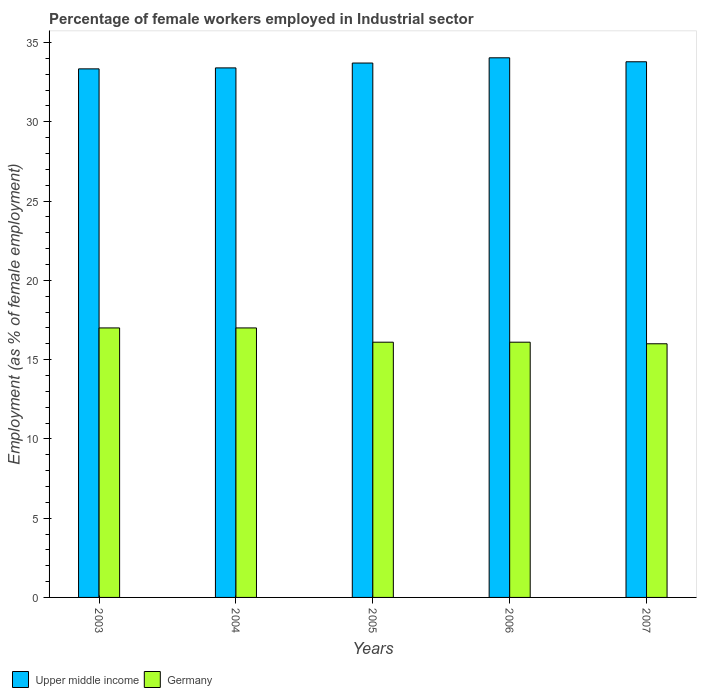How many different coloured bars are there?
Provide a succinct answer. 2. Are the number of bars per tick equal to the number of legend labels?
Provide a succinct answer. Yes. How many bars are there on the 4th tick from the left?
Offer a very short reply. 2. What is the percentage of females employed in Industrial sector in Upper middle income in 2004?
Your answer should be compact. 33.4. Across all years, what is the maximum percentage of females employed in Industrial sector in Upper middle income?
Offer a terse response. 34.04. What is the total percentage of females employed in Industrial sector in Upper middle income in the graph?
Provide a succinct answer. 168.28. What is the difference between the percentage of females employed in Industrial sector in Upper middle income in 2005 and that in 2007?
Your response must be concise. -0.08. What is the difference between the percentage of females employed in Industrial sector in Upper middle income in 2007 and the percentage of females employed in Industrial sector in Germany in 2006?
Ensure brevity in your answer.  17.69. What is the average percentage of females employed in Industrial sector in Upper middle income per year?
Offer a very short reply. 33.66. In the year 2006, what is the difference between the percentage of females employed in Industrial sector in Upper middle income and percentage of females employed in Industrial sector in Germany?
Provide a succinct answer. 17.94. In how many years, is the percentage of females employed in Industrial sector in Upper middle income greater than 17 %?
Keep it short and to the point. 5. What is the ratio of the percentage of females employed in Industrial sector in Germany in 2006 to that in 2007?
Keep it short and to the point. 1.01. What is the difference between the highest and the second highest percentage of females employed in Industrial sector in Germany?
Your response must be concise. 0. What is the difference between the highest and the lowest percentage of females employed in Industrial sector in Upper middle income?
Keep it short and to the point. 0.7. In how many years, is the percentage of females employed in Industrial sector in Upper middle income greater than the average percentage of females employed in Industrial sector in Upper middle income taken over all years?
Your answer should be compact. 3. Is the sum of the percentage of females employed in Industrial sector in Germany in 2003 and 2004 greater than the maximum percentage of females employed in Industrial sector in Upper middle income across all years?
Your answer should be very brief. No. What does the 1st bar from the left in 2007 represents?
Ensure brevity in your answer.  Upper middle income. What does the 2nd bar from the right in 2004 represents?
Keep it short and to the point. Upper middle income. How many bars are there?
Give a very brief answer. 10. How many years are there in the graph?
Ensure brevity in your answer.  5. Does the graph contain grids?
Your answer should be compact. No. How many legend labels are there?
Offer a terse response. 2. How are the legend labels stacked?
Provide a succinct answer. Horizontal. What is the title of the graph?
Your answer should be very brief. Percentage of female workers employed in Industrial sector. Does "Maldives" appear as one of the legend labels in the graph?
Provide a succinct answer. No. What is the label or title of the X-axis?
Offer a terse response. Years. What is the label or title of the Y-axis?
Provide a succinct answer. Employment (as % of female employment). What is the Employment (as % of female employment) of Upper middle income in 2003?
Provide a short and direct response. 33.34. What is the Employment (as % of female employment) in Germany in 2003?
Provide a succinct answer. 17. What is the Employment (as % of female employment) of Upper middle income in 2004?
Offer a terse response. 33.4. What is the Employment (as % of female employment) in Germany in 2004?
Provide a succinct answer. 17. What is the Employment (as % of female employment) of Upper middle income in 2005?
Your answer should be very brief. 33.71. What is the Employment (as % of female employment) in Germany in 2005?
Offer a terse response. 16.1. What is the Employment (as % of female employment) of Upper middle income in 2006?
Provide a succinct answer. 34.04. What is the Employment (as % of female employment) of Germany in 2006?
Offer a terse response. 16.1. What is the Employment (as % of female employment) in Upper middle income in 2007?
Your answer should be compact. 33.79. Across all years, what is the maximum Employment (as % of female employment) in Upper middle income?
Provide a succinct answer. 34.04. Across all years, what is the maximum Employment (as % of female employment) of Germany?
Provide a short and direct response. 17. Across all years, what is the minimum Employment (as % of female employment) in Upper middle income?
Your response must be concise. 33.34. What is the total Employment (as % of female employment) in Upper middle income in the graph?
Your answer should be compact. 168.28. What is the total Employment (as % of female employment) in Germany in the graph?
Give a very brief answer. 82.2. What is the difference between the Employment (as % of female employment) of Upper middle income in 2003 and that in 2004?
Offer a very short reply. -0.06. What is the difference between the Employment (as % of female employment) of Germany in 2003 and that in 2004?
Ensure brevity in your answer.  0. What is the difference between the Employment (as % of female employment) in Upper middle income in 2003 and that in 2005?
Give a very brief answer. -0.37. What is the difference between the Employment (as % of female employment) of Germany in 2003 and that in 2005?
Offer a very short reply. 0.9. What is the difference between the Employment (as % of female employment) of Upper middle income in 2003 and that in 2006?
Keep it short and to the point. -0.7. What is the difference between the Employment (as % of female employment) in Germany in 2003 and that in 2006?
Give a very brief answer. 0.9. What is the difference between the Employment (as % of female employment) of Upper middle income in 2003 and that in 2007?
Make the answer very short. -0.45. What is the difference between the Employment (as % of female employment) in Upper middle income in 2004 and that in 2005?
Your answer should be compact. -0.31. What is the difference between the Employment (as % of female employment) of Germany in 2004 and that in 2005?
Keep it short and to the point. 0.9. What is the difference between the Employment (as % of female employment) of Upper middle income in 2004 and that in 2006?
Your answer should be compact. -0.64. What is the difference between the Employment (as % of female employment) of Upper middle income in 2004 and that in 2007?
Provide a short and direct response. -0.39. What is the difference between the Employment (as % of female employment) of Germany in 2004 and that in 2007?
Keep it short and to the point. 1. What is the difference between the Employment (as % of female employment) in Upper middle income in 2005 and that in 2006?
Offer a very short reply. -0.33. What is the difference between the Employment (as % of female employment) of Germany in 2005 and that in 2006?
Offer a terse response. 0. What is the difference between the Employment (as % of female employment) of Upper middle income in 2005 and that in 2007?
Provide a short and direct response. -0.08. What is the difference between the Employment (as % of female employment) of Germany in 2005 and that in 2007?
Offer a terse response. 0.1. What is the difference between the Employment (as % of female employment) in Upper middle income in 2006 and that in 2007?
Ensure brevity in your answer.  0.25. What is the difference between the Employment (as % of female employment) in Germany in 2006 and that in 2007?
Provide a short and direct response. 0.1. What is the difference between the Employment (as % of female employment) of Upper middle income in 2003 and the Employment (as % of female employment) of Germany in 2004?
Your response must be concise. 16.34. What is the difference between the Employment (as % of female employment) of Upper middle income in 2003 and the Employment (as % of female employment) of Germany in 2005?
Your response must be concise. 17.24. What is the difference between the Employment (as % of female employment) of Upper middle income in 2003 and the Employment (as % of female employment) of Germany in 2006?
Your answer should be very brief. 17.24. What is the difference between the Employment (as % of female employment) of Upper middle income in 2003 and the Employment (as % of female employment) of Germany in 2007?
Your answer should be very brief. 17.34. What is the difference between the Employment (as % of female employment) in Upper middle income in 2004 and the Employment (as % of female employment) in Germany in 2005?
Offer a terse response. 17.3. What is the difference between the Employment (as % of female employment) of Upper middle income in 2004 and the Employment (as % of female employment) of Germany in 2006?
Ensure brevity in your answer.  17.3. What is the difference between the Employment (as % of female employment) of Upper middle income in 2004 and the Employment (as % of female employment) of Germany in 2007?
Give a very brief answer. 17.4. What is the difference between the Employment (as % of female employment) in Upper middle income in 2005 and the Employment (as % of female employment) in Germany in 2006?
Your answer should be very brief. 17.61. What is the difference between the Employment (as % of female employment) in Upper middle income in 2005 and the Employment (as % of female employment) in Germany in 2007?
Offer a very short reply. 17.71. What is the difference between the Employment (as % of female employment) of Upper middle income in 2006 and the Employment (as % of female employment) of Germany in 2007?
Offer a terse response. 18.04. What is the average Employment (as % of female employment) of Upper middle income per year?
Give a very brief answer. 33.66. What is the average Employment (as % of female employment) in Germany per year?
Keep it short and to the point. 16.44. In the year 2003, what is the difference between the Employment (as % of female employment) of Upper middle income and Employment (as % of female employment) of Germany?
Offer a very short reply. 16.34. In the year 2004, what is the difference between the Employment (as % of female employment) of Upper middle income and Employment (as % of female employment) of Germany?
Your answer should be compact. 16.4. In the year 2005, what is the difference between the Employment (as % of female employment) in Upper middle income and Employment (as % of female employment) in Germany?
Your response must be concise. 17.61. In the year 2006, what is the difference between the Employment (as % of female employment) of Upper middle income and Employment (as % of female employment) of Germany?
Make the answer very short. 17.94. In the year 2007, what is the difference between the Employment (as % of female employment) in Upper middle income and Employment (as % of female employment) in Germany?
Provide a short and direct response. 17.79. What is the ratio of the Employment (as % of female employment) of Upper middle income in 2003 to that in 2005?
Offer a very short reply. 0.99. What is the ratio of the Employment (as % of female employment) in Germany in 2003 to that in 2005?
Offer a terse response. 1.06. What is the ratio of the Employment (as % of female employment) of Upper middle income in 2003 to that in 2006?
Make the answer very short. 0.98. What is the ratio of the Employment (as % of female employment) in Germany in 2003 to that in 2006?
Your answer should be very brief. 1.06. What is the ratio of the Employment (as % of female employment) in Upper middle income in 2003 to that in 2007?
Your answer should be very brief. 0.99. What is the ratio of the Employment (as % of female employment) in Germany in 2003 to that in 2007?
Keep it short and to the point. 1.06. What is the ratio of the Employment (as % of female employment) of Upper middle income in 2004 to that in 2005?
Give a very brief answer. 0.99. What is the ratio of the Employment (as % of female employment) in Germany in 2004 to that in 2005?
Keep it short and to the point. 1.06. What is the ratio of the Employment (as % of female employment) in Upper middle income in 2004 to that in 2006?
Your answer should be very brief. 0.98. What is the ratio of the Employment (as % of female employment) in Germany in 2004 to that in 2006?
Provide a succinct answer. 1.06. What is the ratio of the Employment (as % of female employment) in Upper middle income in 2004 to that in 2007?
Your answer should be very brief. 0.99. What is the ratio of the Employment (as % of female employment) of Germany in 2004 to that in 2007?
Offer a terse response. 1.06. What is the ratio of the Employment (as % of female employment) in Upper middle income in 2005 to that in 2006?
Provide a succinct answer. 0.99. What is the ratio of the Employment (as % of female employment) of Germany in 2005 to that in 2006?
Your answer should be compact. 1. What is the ratio of the Employment (as % of female employment) in Upper middle income in 2005 to that in 2007?
Your answer should be very brief. 1. What is the ratio of the Employment (as % of female employment) in Upper middle income in 2006 to that in 2007?
Offer a very short reply. 1.01. What is the ratio of the Employment (as % of female employment) in Germany in 2006 to that in 2007?
Keep it short and to the point. 1.01. What is the difference between the highest and the second highest Employment (as % of female employment) in Upper middle income?
Offer a very short reply. 0.25. What is the difference between the highest and the lowest Employment (as % of female employment) of Upper middle income?
Your answer should be very brief. 0.7. What is the difference between the highest and the lowest Employment (as % of female employment) of Germany?
Provide a succinct answer. 1. 